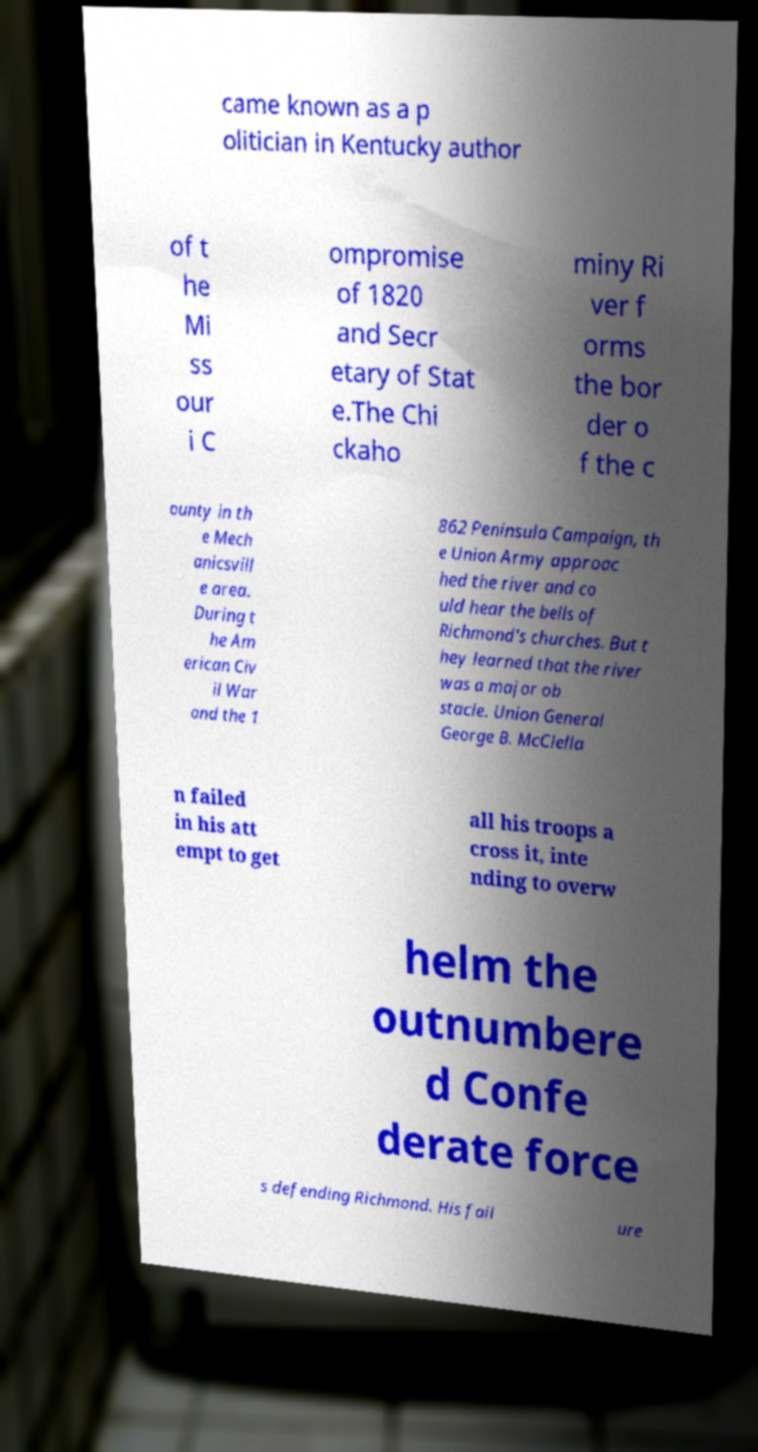Could you assist in decoding the text presented in this image and type it out clearly? came known as a p olitician in Kentucky author of t he Mi ss our i C ompromise of 1820 and Secr etary of Stat e.The Chi ckaho miny Ri ver f orms the bor der o f the c ounty in th e Mech anicsvill e area. During t he Am erican Civ il War and the 1 862 Peninsula Campaign, th e Union Army approac hed the river and co uld hear the bells of Richmond's churches. But t hey learned that the river was a major ob stacle. Union General George B. McClella n failed in his att empt to get all his troops a cross it, inte nding to overw helm the outnumbere d Confe derate force s defending Richmond. His fail ure 